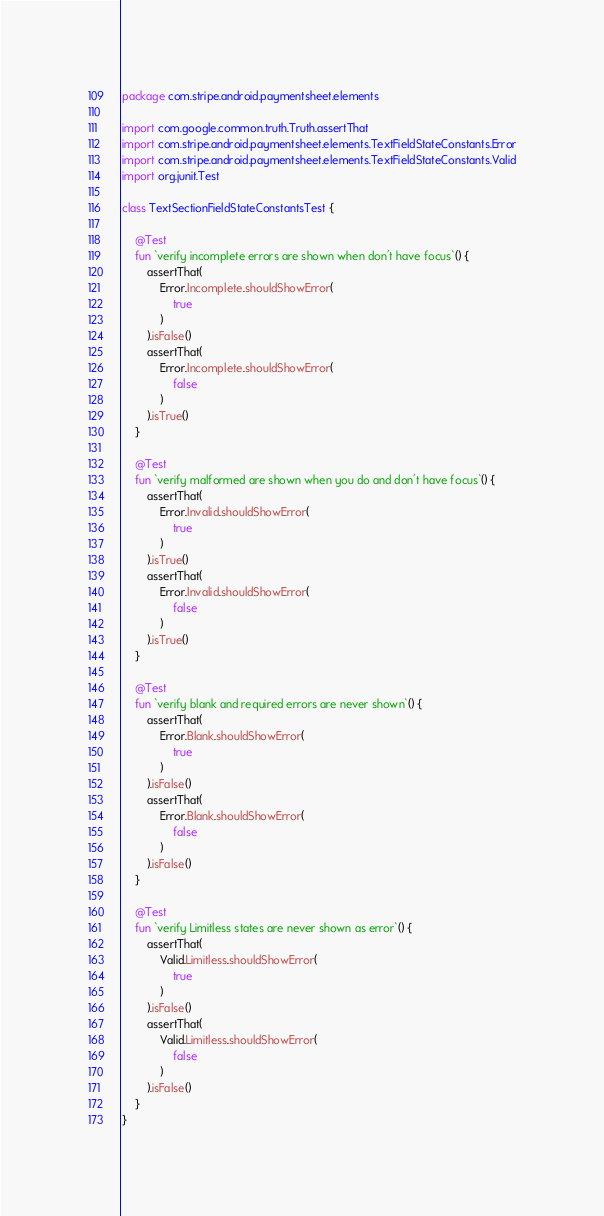Convert code to text. <code><loc_0><loc_0><loc_500><loc_500><_Kotlin_>package com.stripe.android.paymentsheet.elements

import com.google.common.truth.Truth.assertThat
import com.stripe.android.paymentsheet.elements.TextFieldStateConstants.Error
import com.stripe.android.paymentsheet.elements.TextFieldStateConstants.Valid
import org.junit.Test

class TextSectionFieldStateConstantsTest {

    @Test
    fun `verify incomplete errors are shown when don't have focus`() {
        assertThat(
            Error.Incomplete.shouldShowError(
                true
            )
        ).isFalse()
        assertThat(
            Error.Incomplete.shouldShowError(
                false
            )
        ).isTrue()
    }

    @Test
    fun `verify malformed are shown when you do and don't have focus`() {
        assertThat(
            Error.Invalid.shouldShowError(
                true
            )
        ).isTrue()
        assertThat(
            Error.Invalid.shouldShowError(
                false
            )
        ).isTrue()
    }

    @Test
    fun `verify blank and required errors are never shown`() {
        assertThat(
            Error.Blank.shouldShowError(
                true
            )
        ).isFalse()
        assertThat(
            Error.Blank.shouldShowError(
                false
            )
        ).isFalse()
    }

    @Test
    fun `verify Limitless states are never shown as error`() {
        assertThat(
            Valid.Limitless.shouldShowError(
                true
            )
        ).isFalse()
        assertThat(
            Valid.Limitless.shouldShowError(
                false
            )
        ).isFalse()
    }
}
</code> 